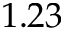Convert formula to latex. <formula><loc_0><loc_0><loc_500><loc_500>1 . 2 3</formula> 